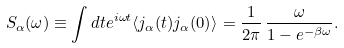Convert formula to latex. <formula><loc_0><loc_0><loc_500><loc_500>S _ { \alpha } ( \omega ) \equiv \int d t e ^ { i \omega t } \langle j _ { \alpha } ( t ) j _ { \alpha } ( 0 ) \rangle = \frac { 1 } { 2 \pi } \, \frac { \omega } { 1 - e ^ { - \beta \omega } } .</formula> 